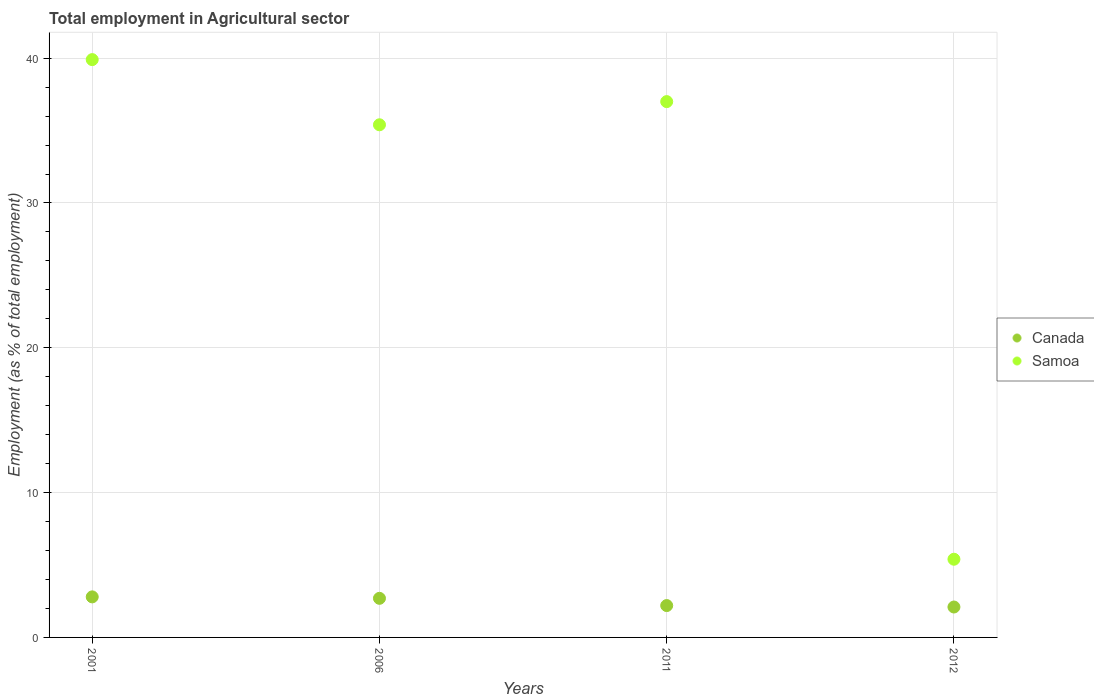What is the employment in agricultural sector in Samoa in 2011?
Give a very brief answer. 37. Across all years, what is the maximum employment in agricultural sector in Samoa?
Give a very brief answer. 39.9. Across all years, what is the minimum employment in agricultural sector in Samoa?
Your answer should be compact. 5.4. In which year was the employment in agricultural sector in Samoa maximum?
Offer a terse response. 2001. In which year was the employment in agricultural sector in Samoa minimum?
Provide a succinct answer. 2012. What is the total employment in agricultural sector in Samoa in the graph?
Provide a short and direct response. 117.7. What is the difference between the employment in agricultural sector in Samoa in 2006 and that in 2011?
Make the answer very short. -1.6. What is the difference between the employment in agricultural sector in Samoa in 2006 and the employment in agricultural sector in Canada in 2011?
Give a very brief answer. 33.2. What is the average employment in agricultural sector in Canada per year?
Provide a short and direct response. 2.45. In the year 2006, what is the difference between the employment in agricultural sector in Canada and employment in agricultural sector in Samoa?
Keep it short and to the point. -32.7. What is the ratio of the employment in agricultural sector in Canada in 2001 to that in 2006?
Provide a short and direct response. 1.04. Is the difference between the employment in agricultural sector in Canada in 2006 and 2012 greater than the difference between the employment in agricultural sector in Samoa in 2006 and 2012?
Give a very brief answer. No. What is the difference between the highest and the second highest employment in agricultural sector in Samoa?
Give a very brief answer. 2.9. What is the difference between the highest and the lowest employment in agricultural sector in Canada?
Offer a terse response. 0.7. Is the employment in agricultural sector in Canada strictly greater than the employment in agricultural sector in Samoa over the years?
Your answer should be very brief. No. How many years are there in the graph?
Provide a succinct answer. 4. What is the difference between two consecutive major ticks on the Y-axis?
Offer a very short reply. 10. Does the graph contain any zero values?
Your answer should be compact. No. Does the graph contain grids?
Ensure brevity in your answer.  Yes. Where does the legend appear in the graph?
Give a very brief answer. Center right. How many legend labels are there?
Offer a very short reply. 2. How are the legend labels stacked?
Ensure brevity in your answer.  Vertical. What is the title of the graph?
Make the answer very short. Total employment in Agricultural sector. What is the label or title of the X-axis?
Give a very brief answer. Years. What is the label or title of the Y-axis?
Offer a very short reply. Employment (as % of total employment). What is the Employment (as % of total employment) of Canada in 2001?
Offer a terse response. 2.8. What is the Employment (as % of total employment) in Samoa in 2001?
Keep it short and to the point. 39.9. What is the Employment (as % of total employment) in Canada in 2006?
Provide a succinct answer. 2.7. What is the Employment (as % of total employment) of Samoa in 2006?
Ensure brevity in your answer.  35.4. What is the Employment (as % of total employment) in Canada in 2011?
Ensure brevity in your answer.  2.2. What is the Employment (as % of total employment) of Canada in 2012?
Offer a terse response. 2.1. What is the Employment (as % of total employment) in Samoa in 2012?
Keep it short and to the point. 5.4. Across all years, what is the maximum Employment (as % of total employment) of Canada?
Your answer should be very brief. 2.8. Across all years, what is the maximum Employment (as % of total employment) in Samoa?
Your response must be concise. 39.9. Across all years, what is the minimum Employment (as % of total employment) in Canada?
Provide a succinct answer. 2.1. Across all years, what is the minimum Employment (as % of total employment) of Samoa?
Provide a short and direct response. 5.4. What is the total Employment (as % of total employment) of Canada in the graph?
Your answer should be very brief. 9.8. What is the total Employment (as % of total employment) in Samoa in the graph?
Keep it short and to the point. 117.7. What is the difference between the Employment (as % of total employment) in Samoa in 2001 and that in 2006?
Provide a succinct answer. 4.5. What is the difference between the Employment (as % of total employment) in Samoa in 2001 and that in 2011?
Make the answer very short. 2.9. What is the difference between the Employment (as % of total employment) of Samoa in 2001 and that in 2012?
Provide a succinct answer. 34.5. What is the difference between the Employment (as % of total employment) in Samoa in 2006 and that in 2011?
Ensure brevity in your answer.  -1.6. What is the difference between the Employment (as % of total employment) of Canada in 2006 and that in 2012?
Provide a succinct answer. 0.6. What is the difference between the Employment (as % of total employment) of Samoa in 2011 and that in 2012?
Your answer should be very brief. 31.6. What is the difference between the Employment (as % of total employment) of Canada in 2001 and the Employment (as % of total employment) of Samoa in 2006?
Your answer should be very brief. -32.6. What is the difference between the Employment (as % of total employment) in Canada in 2001 and the Employment (as % of total employment) in Samoa in 2011?
Offer a terse response. -34.2. What is the difference between the Employment (as % of total employment) in Canada in 2001 and the Employment (as % of total employment) in Samoa in 2012?
Give a very brief answer. -2.6. What is the difference between the Employment (as % of total employment) in Canada in 2006 and the Employment (as % of total employment) in Samoa in 2011?
Your response must be concise. -34.3. What is the difference between the Employment (as % of total employment) of Canada in 2011 and the Employment (as % of total employment) of Samoa in 2012?
Offer a terse response. -3.2. What is the average Employment (as % of total employment) in Canada per year?
Provide a short and direct response. 2.45. What is the average Employment (as % of total employment) in Samoa per year?
Keep it short and to the point. 29.43. In the year 2001, what is the difference between the Employment (as % of total employment) of Canada and Employment (as % of total employment) of Samoa?
Your response must be concise. -37.1. In the year 2006, what is the difference between the Employment (as % of total employment) of Canada and Employment (as % of total employment) of Samoa?
Offer a very short reply. -32.7. In the year 2011, what is the difference between the Employment (as % of total employment) in Canada and Employment (as % of total employment) in Samoa?
Offer a very short reply. -34.8. What is the ratio of the Employment (as % of total employment) of Samoa in 2001 to that in 2006?
Provide a succinct answer. 1.13. What is the ratio of the Employment (as % of total employment) in Canada in 2001 to that in 2011?
Keep it short and to the point. 1.27. What is the ratio of the Employment (as % of total employment) in Samoa in 2001 to that in 2011?
Keep it short and to the point. 1.08. What is the ratio of the Employment (as % of total employment) in Samoa in 2001 to that in 2012?
Your answer should be compact. 7.39. What is the ratio of the Employment (as % of total employment) of Canada in 2006 to that in 2011?
Provide a short and direct response. 1.23. What is the ratio of the Employment (as % of total employment) of Samoa in 2006 to that in 2011?
Offer a very short reply. 0.96. What is the ratio of the Employment (as % of total employment) in Canada in 2006 to that in 2012?
Make the answer very short. 1.29. What is the ratio of the Employment (as % of total employment) of Samoa in 2006 to that in 2012?
Your response must be concise. 6.56. What is the ratio of the Employment (as % of total employment) of Canada in 2011 to that in 2012?
Your answer should be very brief. 1.05. What is the ratio of the Employment (as % of total employment) of Samoa in 2011 to that in 2012?
Keep it short and to the point. 6.85. What is the difference between the highest and the second highest Employment (as % of total employment) in Samoa?
Offer a very short reply. 2.9. What is the difference between the highest and the lowest Employment (as % of total employment) in Samoa?
Your answer should be compact. 34.5. 